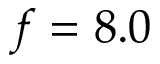<formula> <loc_0><loc_0><loc_500><loc_500>f = 8 . 0</formula> 